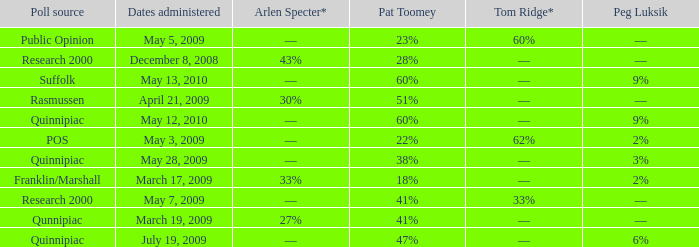Which Poll source has an Arlen Specter* of ––, and a Tom Ridge* of 60%? Public Opinion. 